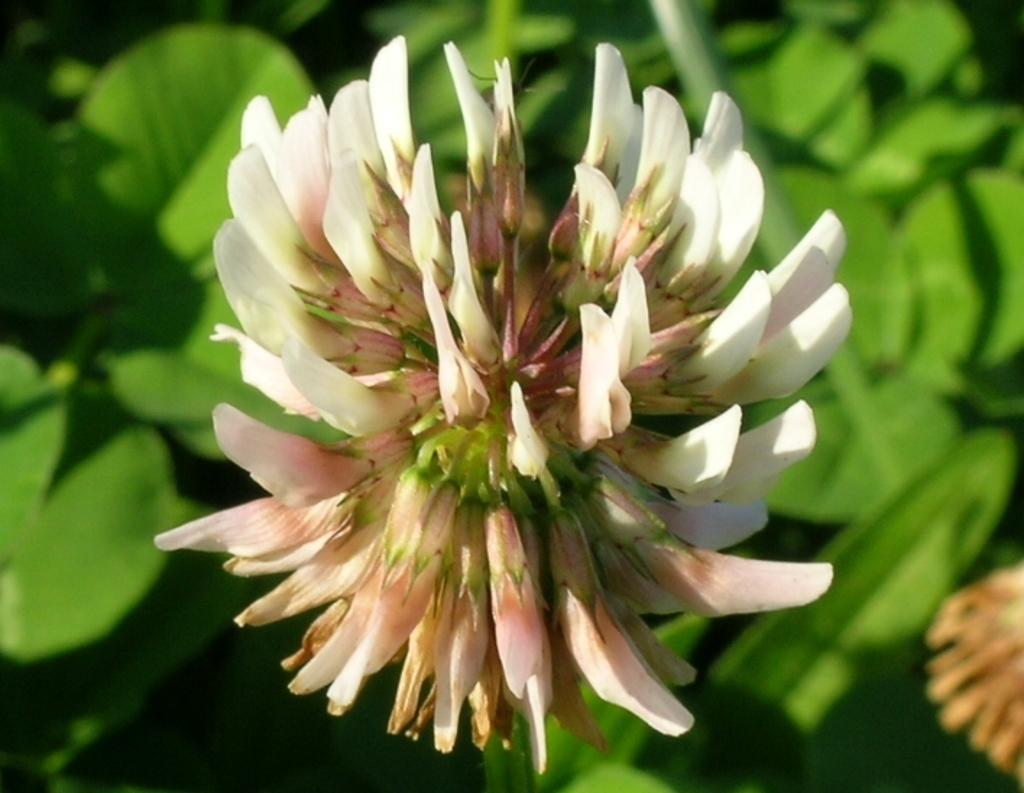What type of flower is in the image? There is a white flower in the image. What color are the leaves in the background of the image? The leaves in the background of the image are green. What story do the giants tell each other while holding the white flower in the image? There are no giants or storytelling depicted in the image; it only features a white flower and green leaves. 